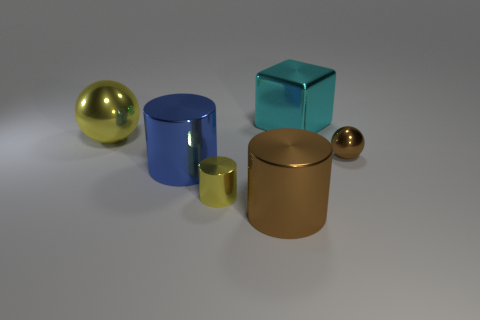What is the size of the cylinder that is the same color as the big metal ball?
Your response must be concise. Small. What number of objects are either balls behind the small brown thing or brown metal things that are on the right side of the big cyan block?
Offer a terse response. 2. Are there more tiny brown objects than large green objects?
Make the answer very short. Yes. There is a sphere that is to the right of the large brown metal cylinder; what is its color?
Give a very brief answer. Brown. Does the blue thing have the same shape as the large brown thing?
Your answer should be very brief. Yes. What is the color of the big object that is on the left side of the big cyan object and on the right side of the big blue metal object?
Your answer should be very brief. Brown. There is a brown shiny thing right of the cyan object; does it have the same size as the yellow object that is in front of the large shiny sphere?
Offer a very short reply. Yes. What number of objects are either brown things on the right side of the cyan metal block or small cylinders?
Your response must be concise. 2. Is the size of the yellow metal sphere the same as the blue metal thing?
Provide a succinct answer. Yes. What number of blocks are tiny yellow objects or big brown shiny things?
Give a very brief answer. 0. 